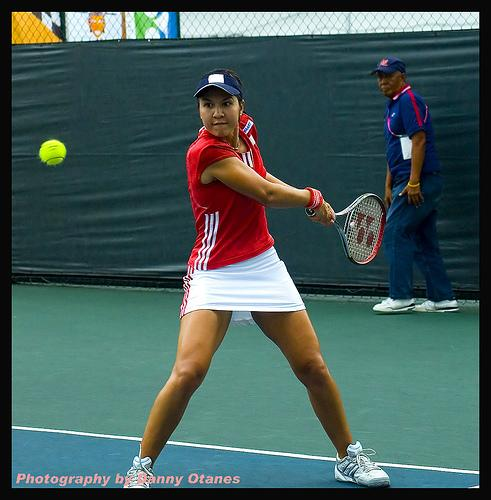Highlight the main character and their surroundings in the image. A woman playing tennis is the key focus, surrounded by a tennis court, linesman, and a chain link fence. List the three main elements in the image, such as the person, object, and action. Woman, tennis racquet, and hitting a tennis ball Summarize the primary action happening in the image, focusing on the person and their role. A tennis player is in the middle of a game, striking a ball with her racquet. Elaborate on the essential action and attire of the person at the focus of the image. A female tennis player is striking a yellow ball, dressed in a red and white outfit with a blue visor and wristband. Using natural language, provide an overview of the image's central theme and main subject. In this picture, we see a woman actively playing tennis on a court, skillfully swinging her racquet to hit the ball. Identify the primary activity taking place in the image and mention the central figure involved. A woman is playing tennis, holding her racquet with both hands and swinging at the ball. Briefly describe the focal point of the image, including the subject's clothing and activity. The image centers on a woman wearing a visor and tennis outfit, busily engaged in a tennis match. State the main subject of the image and describe their appearance and current activity. The central figure is a woman wearing a tennis uniform, playing tennis by swinging at a ball with her racquet. Capture the essence of the image by emphasizing the key participant and their ongoing action. A determined woman in a tennis outfit unhesitatingly hits a tennis ball using her racquet during an intense game. Mention the key components that create the scene and center of attention in the image. The image features a woman wearing a tennis outfit, holding a racquet, and hitting a tennis ball on the court. 